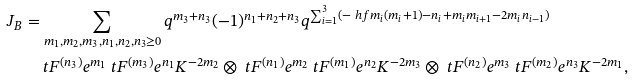Convert formula to latex. <formula><loc_0><loc_0><loc_500><loc_500>J _ { B } & = \sum _ { m _ { 1 } , m _ { 2 } , m _ { 3 } , n _ { 1 } , n _ { 2 } , n _ { 3 } \geq 0 } q ^ { m _ { 3 } + n _ { 3 } } ( - 1 ) ^ { n _ { 1 } + n _ { 2 } + n _ { 3 } } q ^ { \sum _ { i = 1 } ^ { 3 } ( - \ h f m _ { i } ( m _ { i } + 1 ) - n _ { i } + m _ { i } m _ { i + 1 } - 2 m _ { i } n _ { i - 1 } ) } \\ & \quad \ t F ^ { ( n _ { 3 } ) } e ^ { m _ { 1 } } \ t F ^ { ( m _ { 3 } ) } e ^ { n _ { 1 } } K ^ { - 2 m _ { 2 } } \otimes \ t F ^ { ( n _ { 1 } ) } e ^ { m _ { 2 } } \ t F ^ { ( m _ { 1 } ) } e ^ { n _ { 2 } } K ^ { - 2 m _ { 3 } } \otimes \ t F ^ { ( n _ { 2 } ) } e ^ { m _ { 3 } } \ t F ^ { ( m _ { 2 } ) } e ^ { n _ { 3 } } K ^ { - 2 m _ { 1 } } ,</formula> 